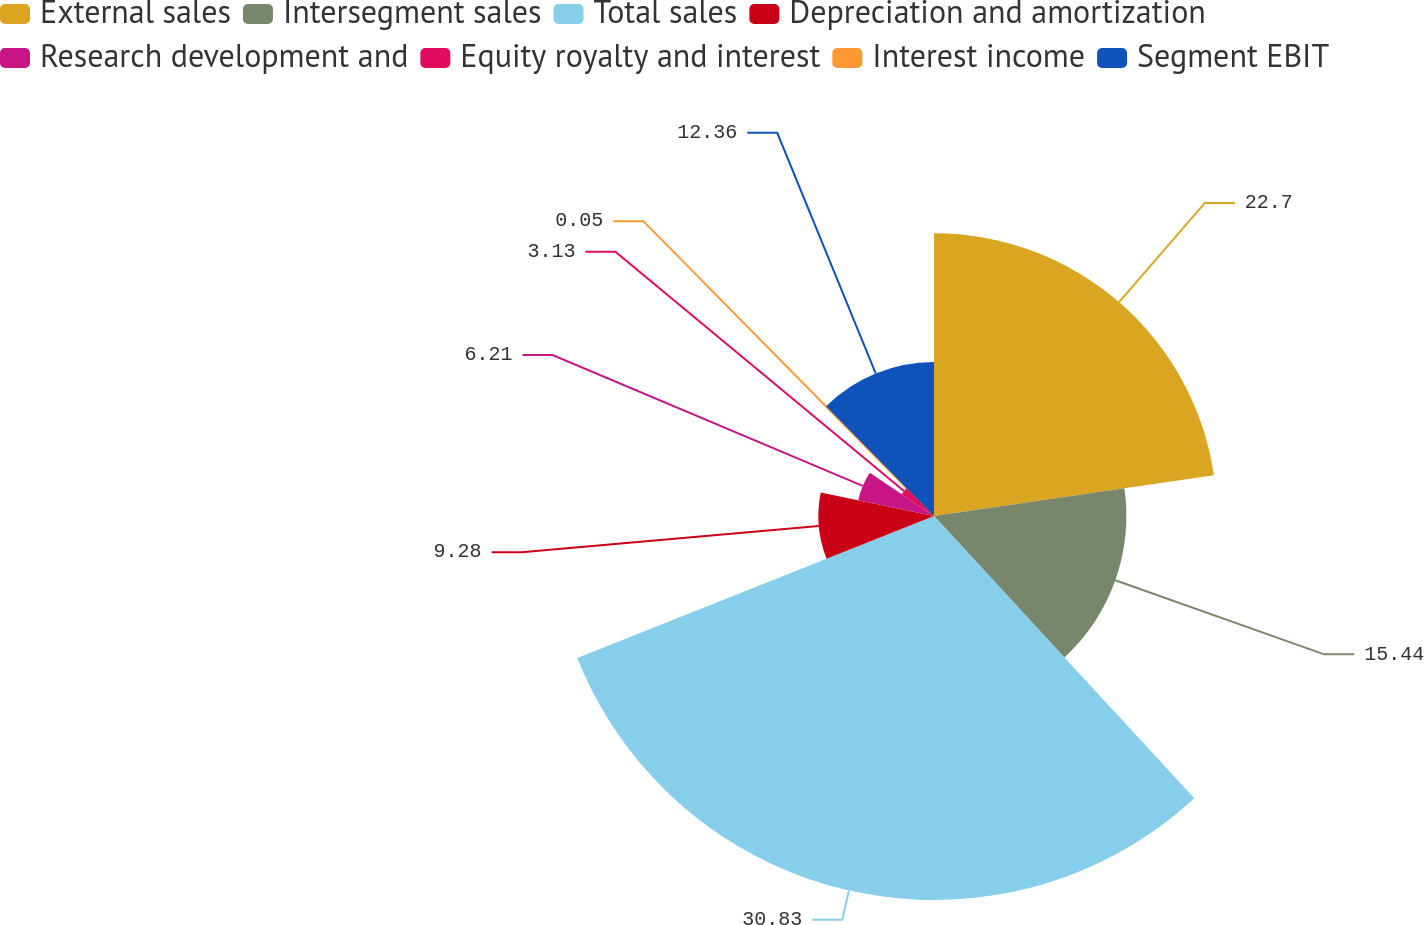Convert chart to OTSL. <chart><loc_0><loc_0><loc_500><loc_500><pie_chart><fcel>External sales<fcel>Intersegment sales<fcel>Total sales<fcel>Depreciation and amortization<fcel>Research development and<fcel>Equity royalty and interest<fcel>Interest income<fcel>Segment EBIT<nl><fcel>22.7%<fcel>15.44%<fcel>30.82%<fcel>9.28%<fcel>6.21%<fcel>3.13%<fcel>0.05%<fcel>12.36%<nl></chart> 